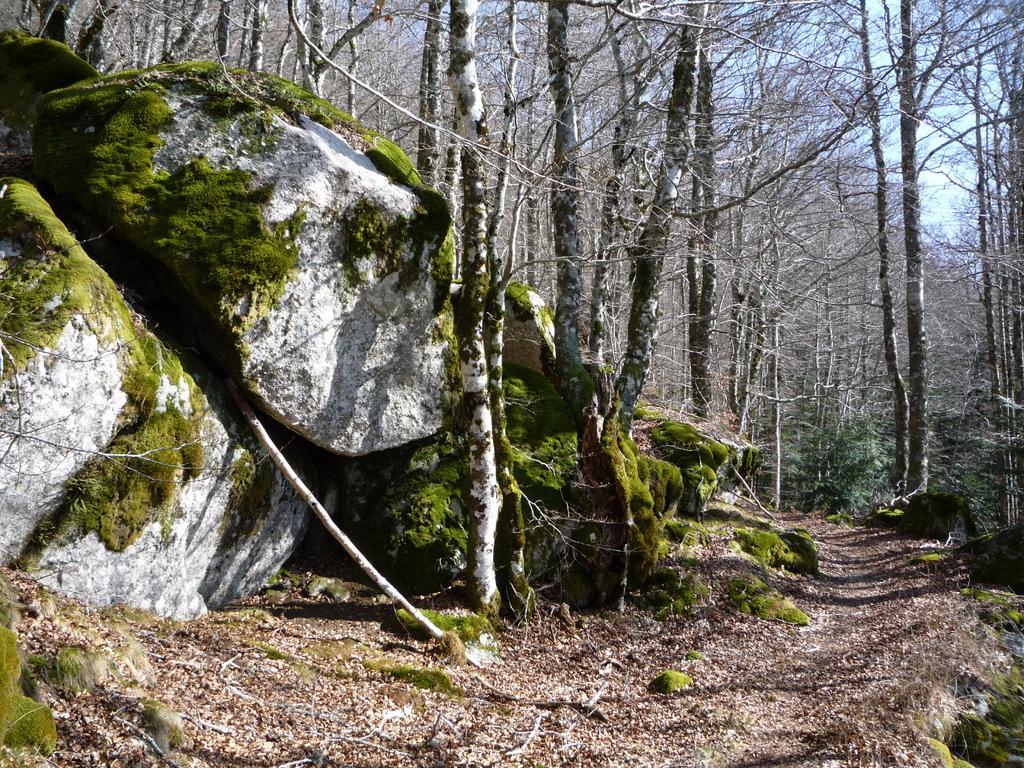Describe this image in one or two sentences. This image is taken outdoors. At the bottom of the image there is a ground with grass and many dry leaves on it. At the top of the image there is the sky with clouds. In the background there are many trees and plants with stems, branches and leaves. On the left side of the image there are a few rocks and there is an algae on the rocks. 